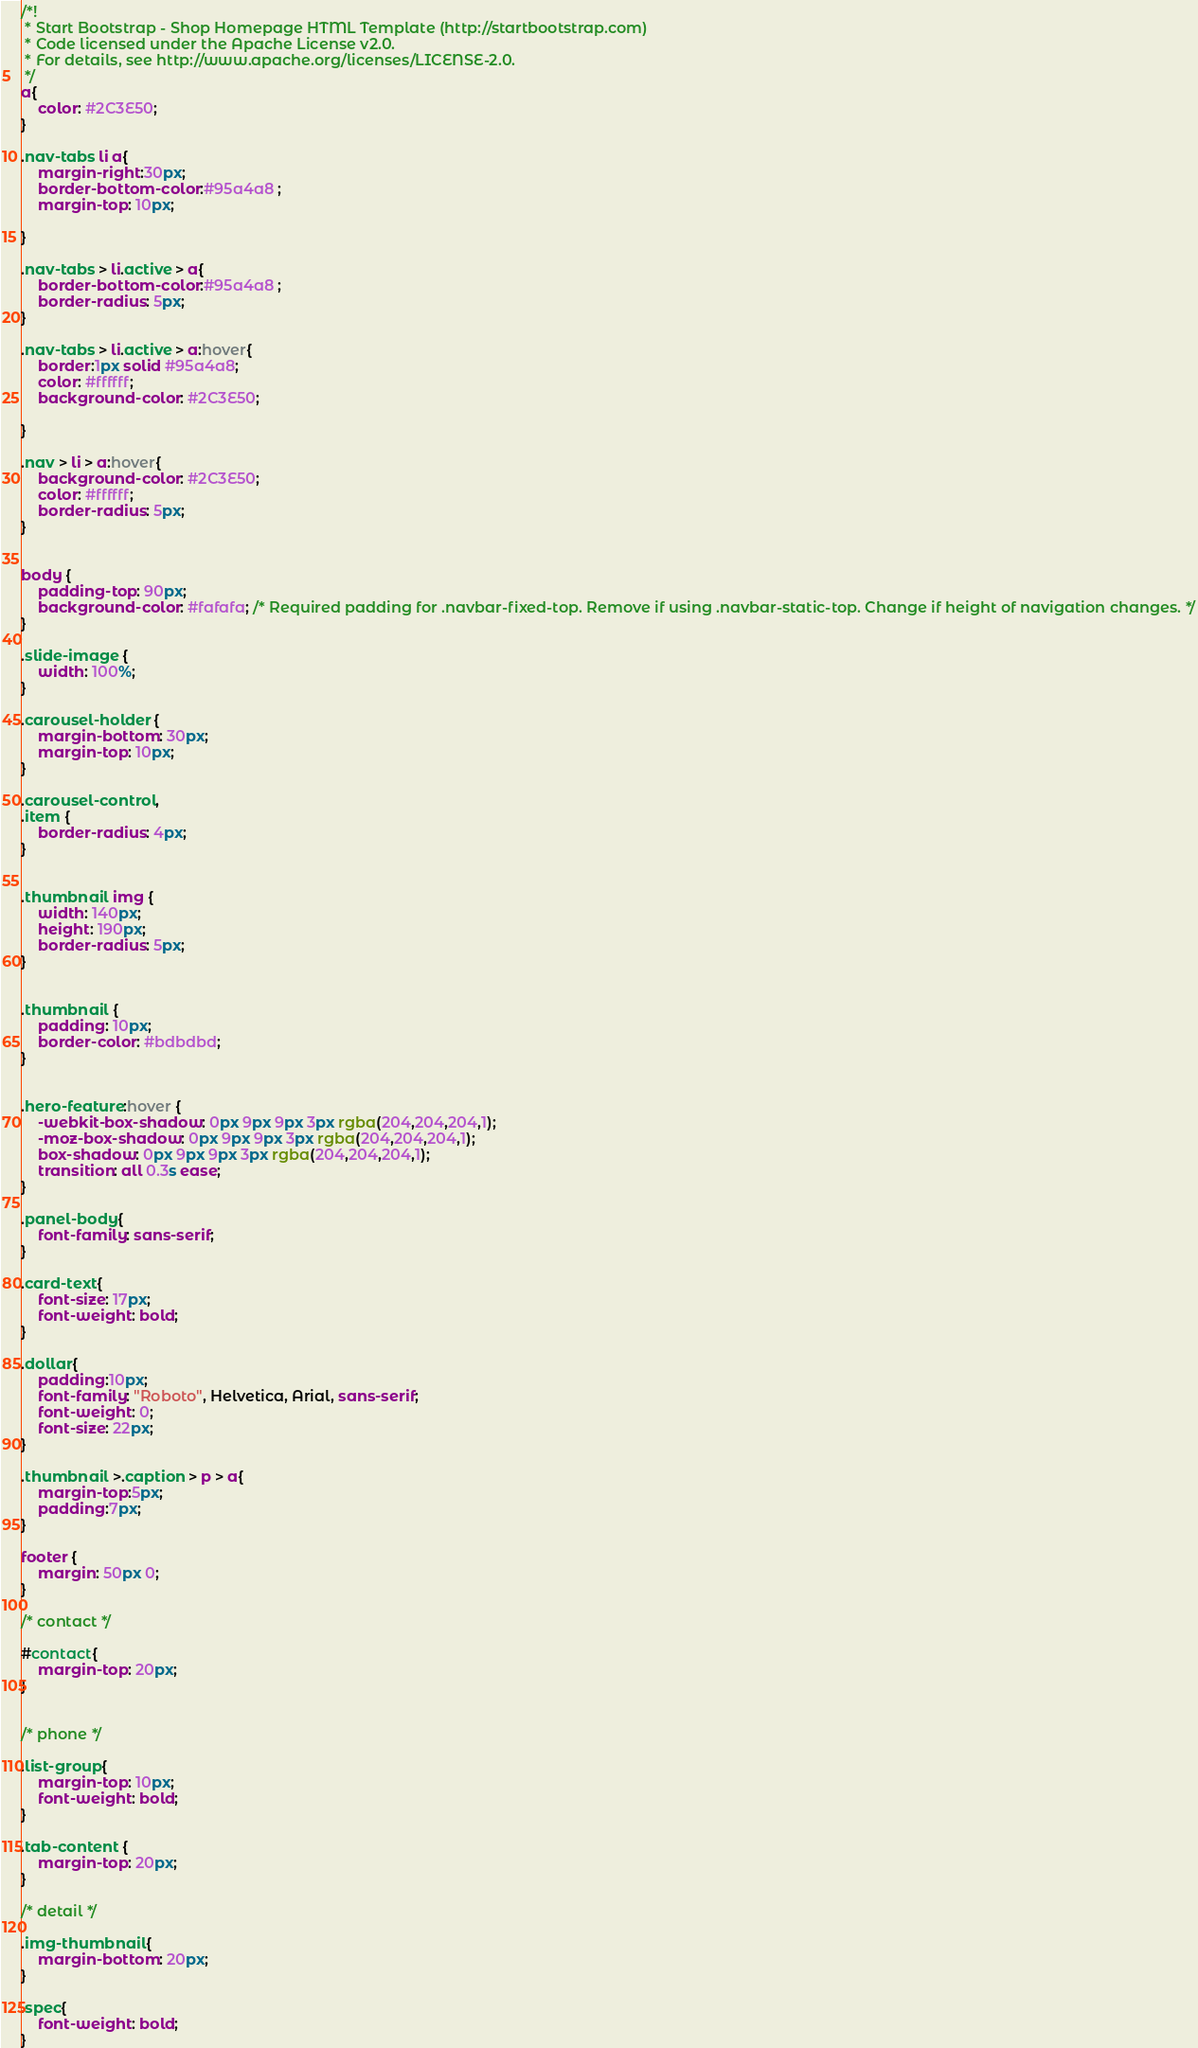Convert code to text. <code><loc_0><loc_0><loc_500><loc_500><_CSS_>/*!
 * Start Bootstrap - Shop Homepage HTML Template (http://startbootstrap.com)
 * Code licensed under the Apache License v2.0.
 * For details, see http://www.apache.org/licenses/LICENSE-2.0.
 */
a{
    color: #2C3E50;
}

.nav-tabs li a{
    margin-right:30px;
    border-bottom-color:#95a4a8 ;
    margin-top: 10px;

}

.nav-tabs > li.active > a{
    border-bottom-color:#95a4a8 ;
    border-radius: 5px;
}

.nav-tabs > li.active > a:hover{
    border:1px solid #95a4a8;
    color: #ffffff;
    background-color: #2C3E50;

} 

.nav > li > a:hover{
    background-color: #2C3E50;
    color: #ffffff;
    border-radius: 5px;    
}


body {
    padding-top: 90px;
    background-color: #fafafa; /* Required padding for .navbar-fixed-top. Remove if using .navbar-static-top. Change if height of navigation changes. */
}

.slide-image {
    width: 100%;
}

.carousel-holder {
    margin-bottom: 30px;
    margin-top: 10px;
}

.carousel-control,
.item {
    border-radius: 4px;
}


.thumbnail img {
    width: 140px;
    height: 190px;
    border-radius: 5px;
}


.thumbnail {
    padding: 10px;
    border-color: #bdbdbd;
}


.hero-feature:hover {
    -webkit-box-shadow: 0px 9px 9px 3px rgba(204,204,204,1);
    -moz-box-shadow: 0px 9px 9px 3px rgba(204,204,204,1);
    box-shadow: 0px 9px 9px 3px rgba(204,204,204,1);
    transition: all 0.3s ease;
}

.panel-body{
    font-family: sans-serif;
}

.card-text{
    font-size: 17px;
    font-weight: bold;
}

.dollar{
    padding:10px;
    font-family: "Roboto", Helvetica, Arial, sans-serif;
    font-weight: 0;
    font-size: 22px;
}

.thumbnail >.caption > p > a{
    margin-top:5px; 
    padding:7px;
}

footer {
    margin: 50px 0;
}

/* contact */

#contact{
    margin-top: 20px;
}


/* phone */

.list-group{
    margin-top: 10px;
    font-weight: bold;
}

.tab-content {
    margin-top: 20px;
}

/* detail */

.img-thumbnail{
    margin-bottom: 20px;
}

.spec{
    font-weight: bold;
}</code> 